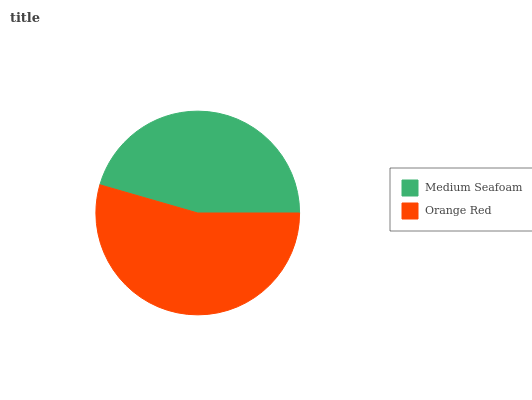Is Medium Seafoam the minimum?
Answer yes or no. Yes. Is Orange Red the maximum?
Answer yes or no. Yes. Is Orange Red the minimum?
Answer yes or no. No. Is Orange Red greater than Medium Seafoam?
Answer yes or no. Yes. Is Medium Seafoam less than Orange Red?
Answer yes or no. Yes. Is Medium Seafoam greater than Orange Red?
Answer yes or no. No. Is Orange Red less than Medium Seafoam?
Answer yes or no. No. Is Orange Red the high median?
Answer yes or no. Yes. Is Medium Seafoam the low median?
Answer yes or no. Yes. Is Medium Seafoam the high median?
Answer yes or no. No. Is Orange Red the low median?
Answer yes or no. No. 